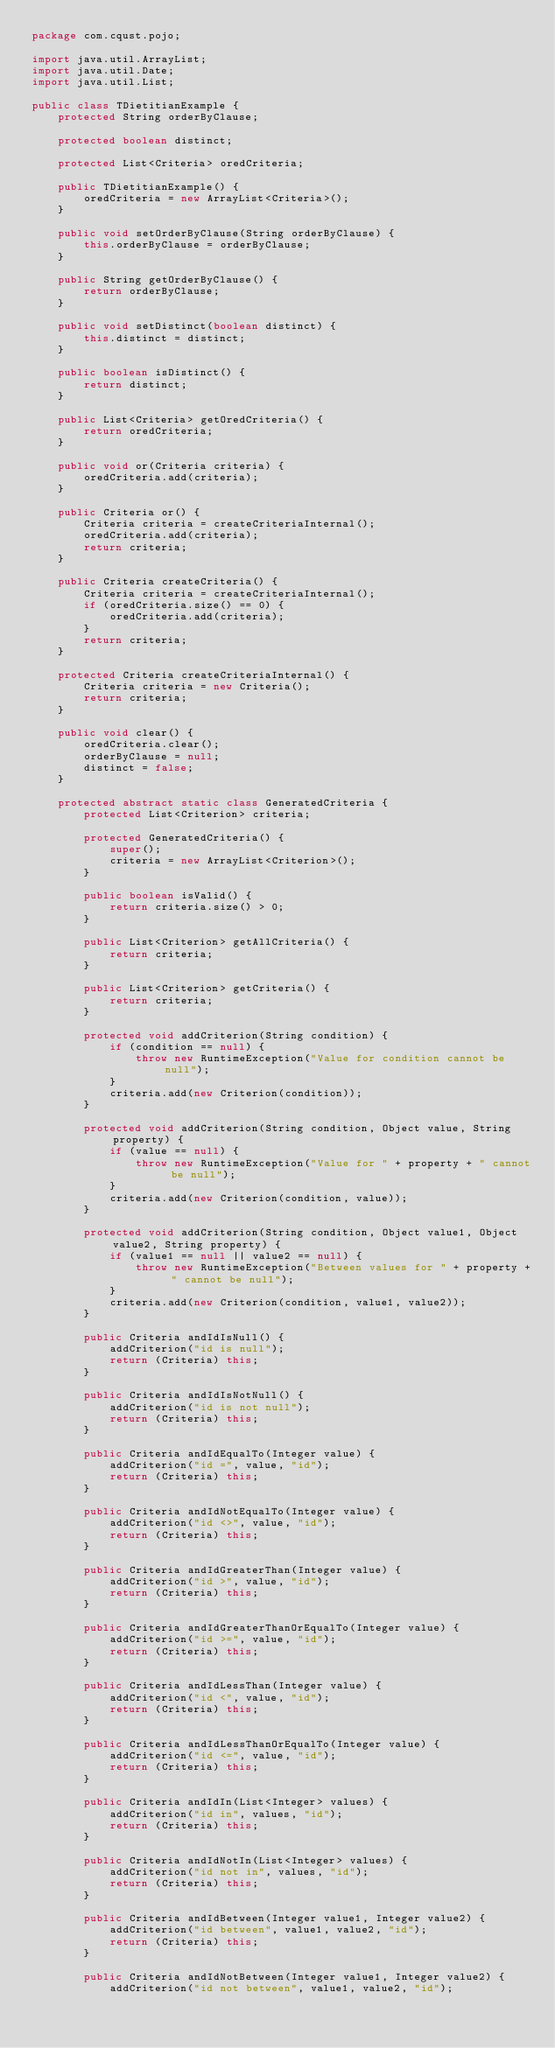<code> <loc_0><loc_0><loc_500><loc_500><_Java_>package com.cqust.pojo;

import java.util.ArrayList;
import java.util.Date;
import java.util.List;

public class TDietitianExample {
    protected String orderByClause;

    protected boolean distinct;

    protected List<Criteria> oredCriteria;

    public TDietitianExample() {
        oredCriteria = new ArrayList<Criteria>();
    }

    public void setOrderByClause(String orderByClause) {
        this.orderByClause = orderByClause;
    }

    public String getOrderByClause() {
        return orderByClause;
    }

    public void setDistinct(boolean distinct) {
        this.distinct = distinct;
    }

    public boolean isDistinct() {
        return distinct;
    }

    public List<Criteria> getOredCriteria() {
        return oredCriteria;
    }

    public void or(Criteria criteria) {
        oredCriteria.add(criteria);
    }

    public Criteria or() {
        Criteria criteria = createCriteriaInternal();
        oredCriteria.add(criteria);
        return criteria;
    }

    public Criteria createCriteria() {
        Criteria criteria = createCriteriaInternal();
        if (oredCriteria.size() == 0) {
            oredCriteria.add(criteria);
        }
        return criteria;
    }

    protected Criteria createCriteriaInternal() {
        Criteria criteria = new Criteria();
        return criteria;
    }

    public void clear() {
        oredCriteria.clear();
        orderByClause = null;
        distinct = false;
    }

    protected abstract static class GeneratedCriteria {
        protected List<Criterion> criteria;

        protected GeneratedCriteria() {
            super();
            criteria = new ArrayList<Criterion>();
        }

        public boolean isValid() {
            return criteria.size() > 0;
        }

        public List<Criterion> getAllCriteria() {
            return criteria;
        }

        public List<Criterion> getCriteria() {
            return criteria;
        }

        protected void addCriterion(String condition) {
            if (condition == null) {
                throw new RuntimeException("Value for condition cannot be null");
            }
            criteria.add(new Criterion(condition));
        }

        protected void addCriterion(String condition, Object value, String property) {
            if (value == null) {
                throw new RuntimeException("Value for " + property + " cannot be null");
            }
            criteria.add(new Criterion(condition, value));
        }

        protected void addCriterion(String condition, Object value1, Object value2, String property) {
            if (value1 == null || value2 == null) {
                throw new RuntimeException("Between values for " + property + " cannot be null");
            }
            criteria.add(new Criterion(condition, value1, value2));
        }

        public Criteria andIdIsNull() {
            addCriterion("id is null");
            return (Criteria) this;
        }

        public Criteria andIdIsNotNull() {
            addCriterion("id is not null");
            return (Criteria) this;
        }

        public Criteria andIdEqualTo(Integer value) {
            addCriterion("id =", value, "id");
            return (Criteria) this;
        }

        public Criteria andIdNotEqualTo(Integer value) {
            addCriterion("id <>", value, "id");
            return (Criteria) this;
        }

        public Criteria andIdGreaterThan(Integer value) {
            addCriterion("id >", value, "id");
            return (Criteria) this;
        }

        public Criteria andIdGreaterThanOrEqualTo(Integer value) {
            addCriterion("id >=", value, "id");
            return (Criteria) this;
        }

        public Criteria andIdLessThan(Integer value) {
            addCriterion("id <", value, "id");
            return (Criteria) this;
        }

        public Criteria andIdLessThanOrEqualTo(Integer value) {
            addCriterion("id <=", value, "id");
            return (Criteria) this;
        }

        public Criteria andIdIn(List<Integer> values) {
            addCriterion("id in", values, "id");
            return (Criteria) this;
        }

        public Criteria andIdNotIn(List<Integer> values) {
            addCriterion("id not in", values, "id");
            return (Criteria) this;
        }

        public Criteria andIdBetween(Integer value1, Integer value2) {
            addCriterion("id between", value1, value2, "id");
            return (Criteria) this;
        }

        public Criteria andIdNotBetween(Integer value1, Integer value2) {
            addCriterion("id not between", value1, value2, "id");</code> 